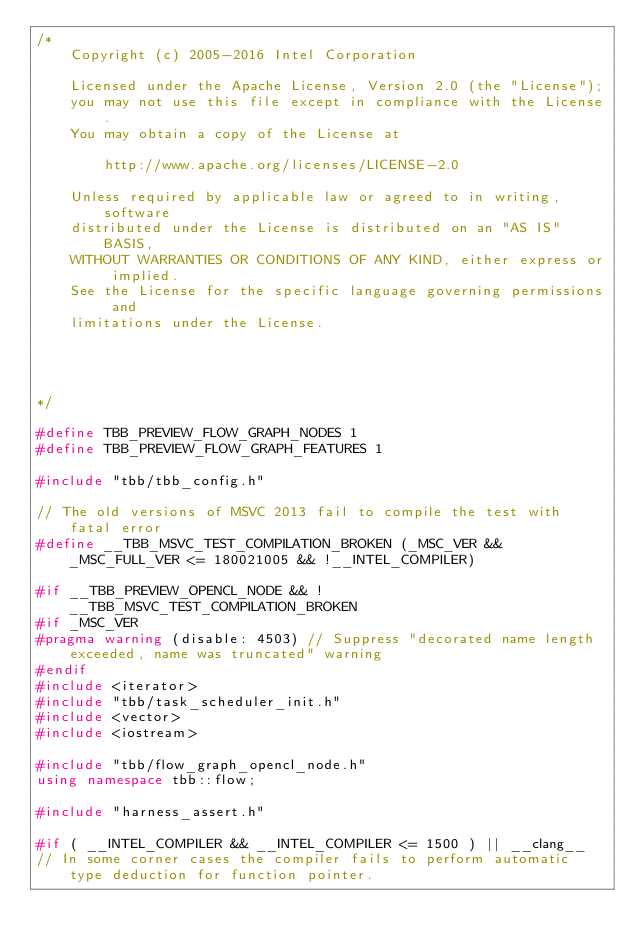Convert code to text. <code><loc_0><loc_0><loc_500><loc_500><_C++_>/*
    Copyright (c) 2005-2016 Intel Corporation

    Licensed under the Apache License, Version 2.0 (the "License");
    you may not use this file except in compliance with the License.
    You may obtain a copy of the License at

        http://www.apache.org/licenses/LICENSE-2.0

    Unless required by applicable law or agreed to in writing, software
    distributed under the License is distributed on an "AS IS" BASIS,
    WITHOUT WARRANTIES OR CONDITIONS OF ANY KIND, either express or implied.
    See the License for the specific language governing permissions and
    limitations under the License.




*/

#define TBB_PREVIEW_FLOW_GRAPH_NODES 1
#define TBB_PREVIEW_FLOW_GRAPH_FEATURES 1

#include "tbb/tbb_config.h"

// The old versions of MSVC 2013 fail to compile the test with fatal error
#define __TBB_MSVC_TEST_COMPILATION_BROKEN (_MSC_VER && _MSC_FULL_VER <= 180021005 && !__INTEL_COMPILER)

#if __TBB_PREVIEW_OPENCL_NODE && !__TBB_MSVC_TEST_COMPILATION_BROKEN
#if _MSC_VER
#pragma warning (disable: 4503) // Suppress "decorated name length exceeded, name was truncated" warning
#endif
#include <iterator>
#include "tbb/task_scheduler_init.h"
#include <vector>
#include <iostream>

#include "tbb/flow_graph_opencl_node.h"
using namespace tbb::flow;

#include "harness_assert.h"

#if ( __INTEL_COMPILER && __INTEL_COMPILER <= 1500 ) || __clang__
// In some corner cases the compiler fails to perform automatic type deduction for function pointer.</code> 